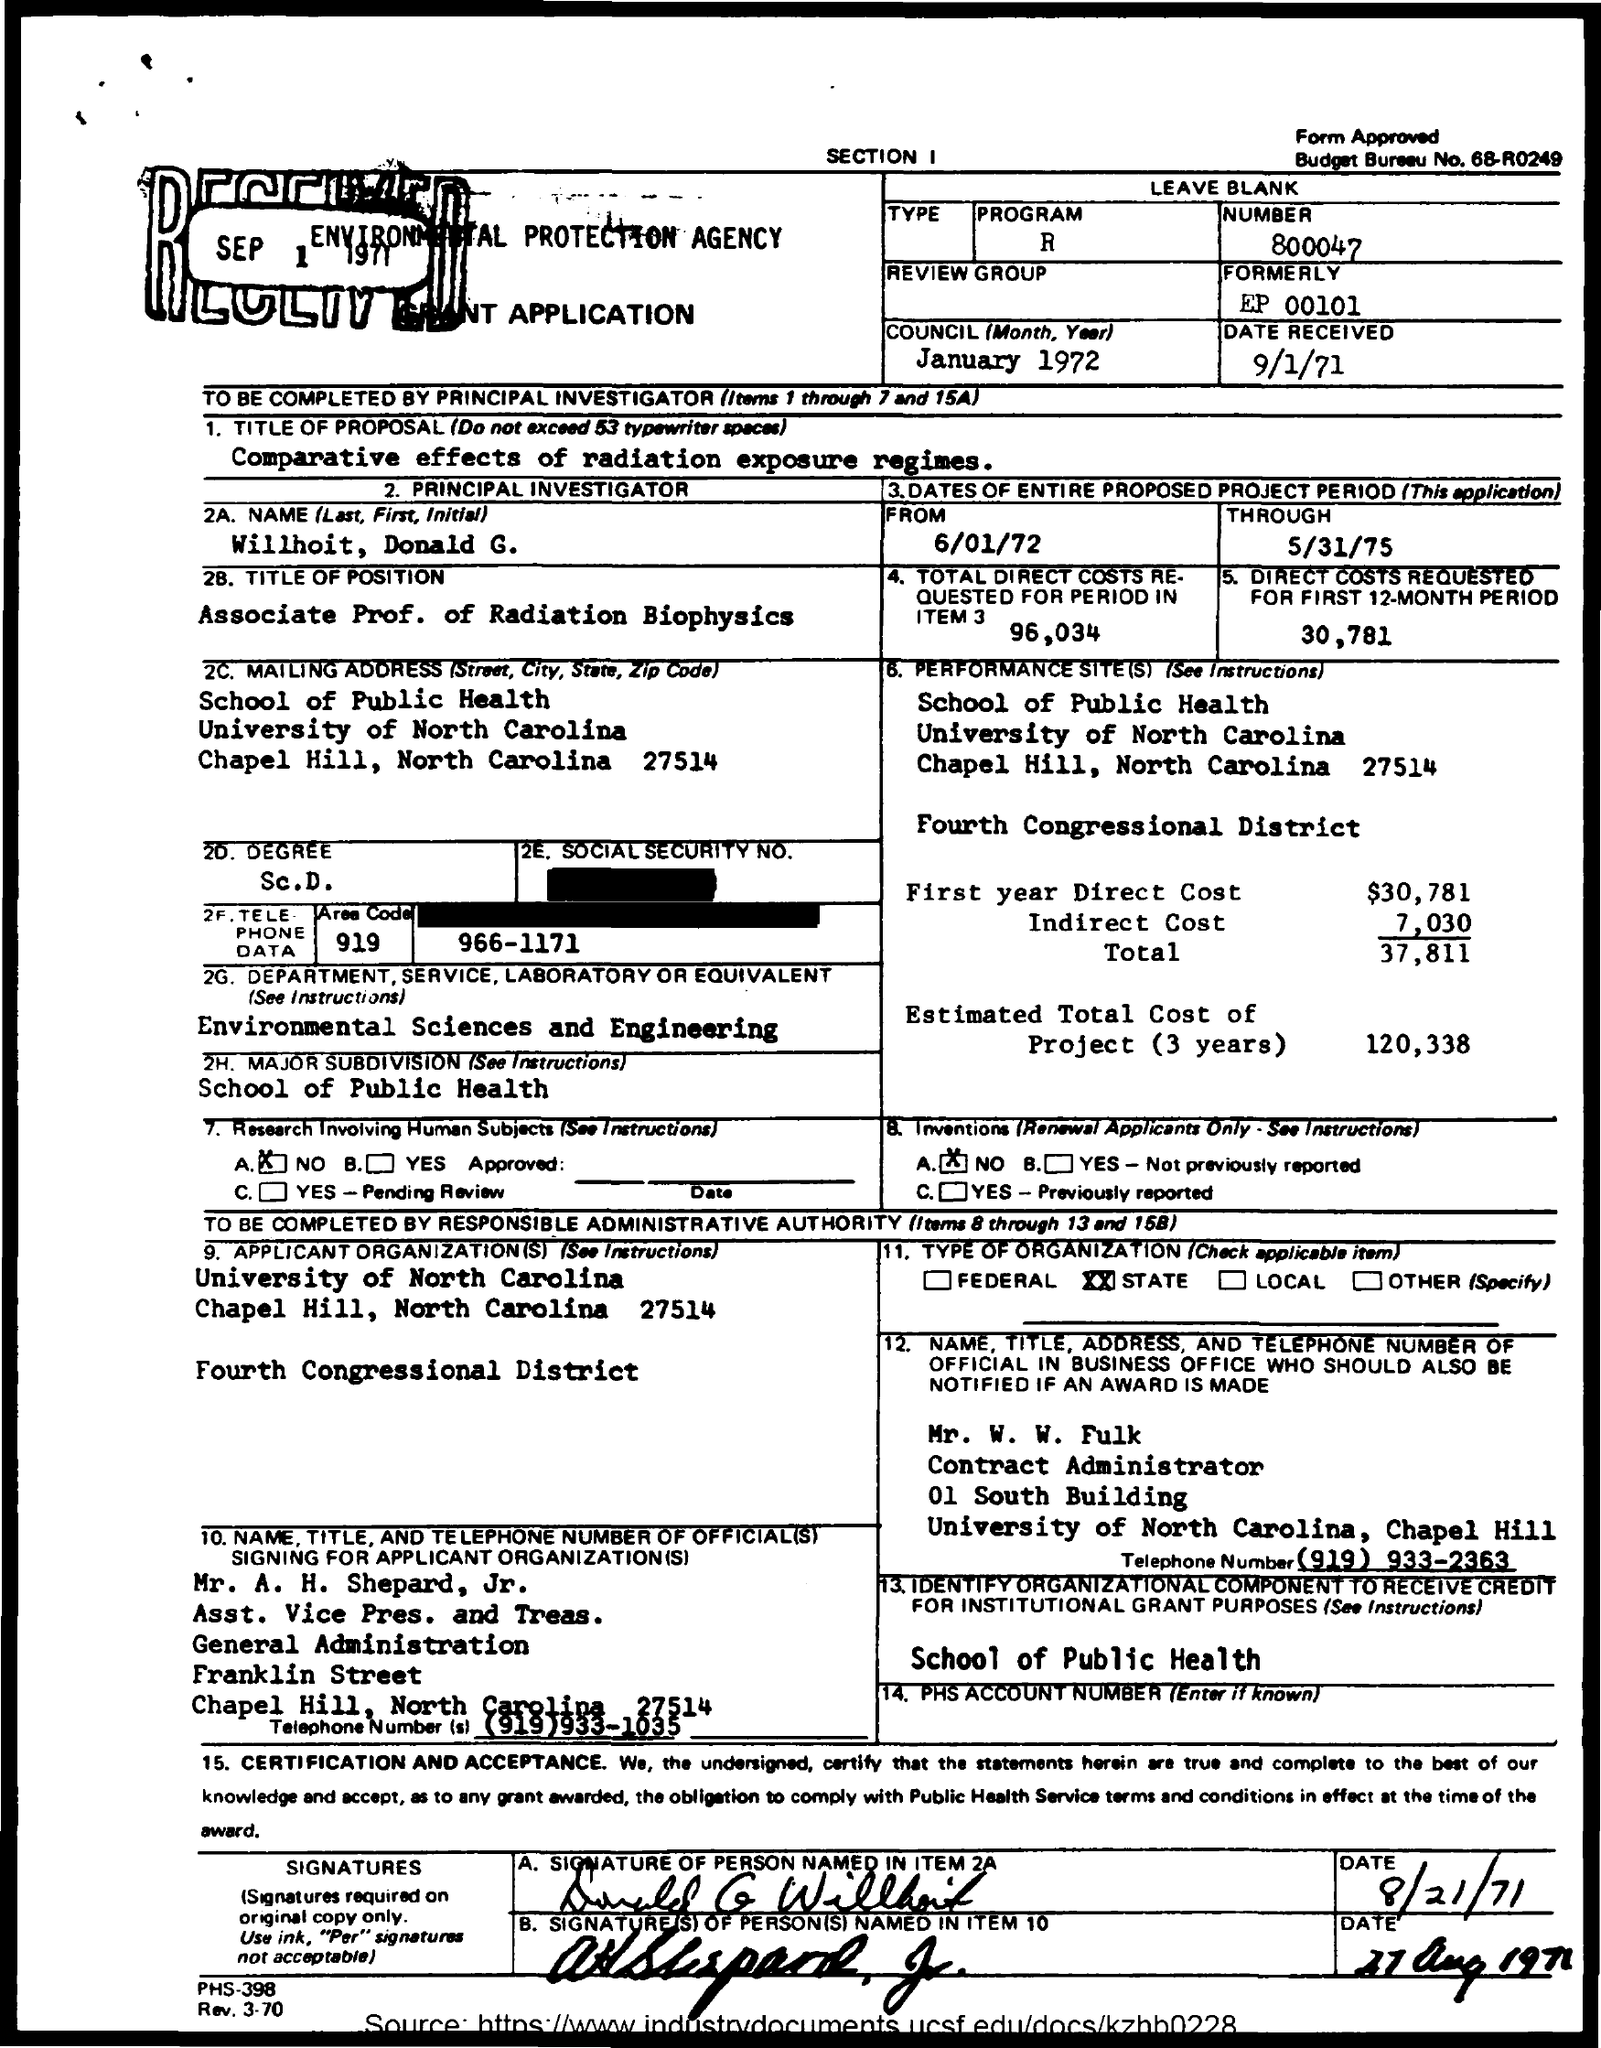What is the received date of the grant application?
Offer a very short reply. 9/1/71. What is the title of the proposal given in the application?
Keep it short and to the point. Comparative effects of radiation exposure regimes. Who is the principal investigator as per the application?
Keep it short and to the point. WILLHOIT, DONALD G. What is the title of position of Willhoit, Donald G.?
Make the answer very short. ASSOCIATE PROF. OF RADIATION BIOPHYSICS. What is the total direct costs requested for period in Item 3?
Give a very brief answer. 96,034. What is the total direct costs requested for first 12-month period?
Your answer should be very brief. 30,781. What is the start date of entire proposed project period?
Your answer should be very brief. 6/01/72. What is the estimated total direct cost of project (3 years)?
Your response must be concise. 120,338. 